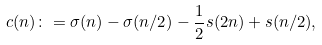<formula> <loc_0><loc_0><loc_500><loc_500>c ( n ) \colon = \sigma ( n ) - \sigma ( n / 2 ) - \frac { 1 } { 2 } s ( 2 n ) + s ( n / 2 ) ,</formula> 